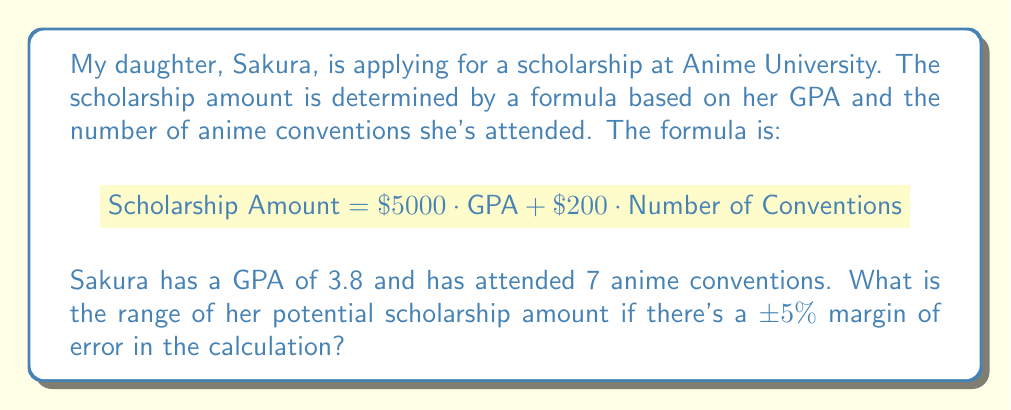Give your solution to this math problem. Let's approach this step-by-step:

1) First, we calculate the base scholarship amount:
   
   $5000 \cdot \text{GPA} + $200 \cdot \text{Number of Conventions}$
   $= $5000 \cdot 3.8 + $200 \cdot 7$
   $= $19,000 + $1,400$
   $= $20,400$

2) Now, we need to calculate the 5% margin of error:
   
   $5\% \text{ of } $20,400 = 0.05 \cdot $20,400 = $1,020$

3) To find the range, we subtract $1,020 from $20,400 for the lower bound and add $1,020 to $20,400 for the upper bound:

   Lower bound: $20,400 - $1,020 = $19,380$
   Upper bound: $20,400 + $1,020 = $21,420$

4) Therefore, the range of the potential scholarship amount is:

   $$19,380 \leq \text{Scholarship Amount} \leq 21,420$$
Answer: The potential scholarship amount ranges from $19,380 to $21,420. 